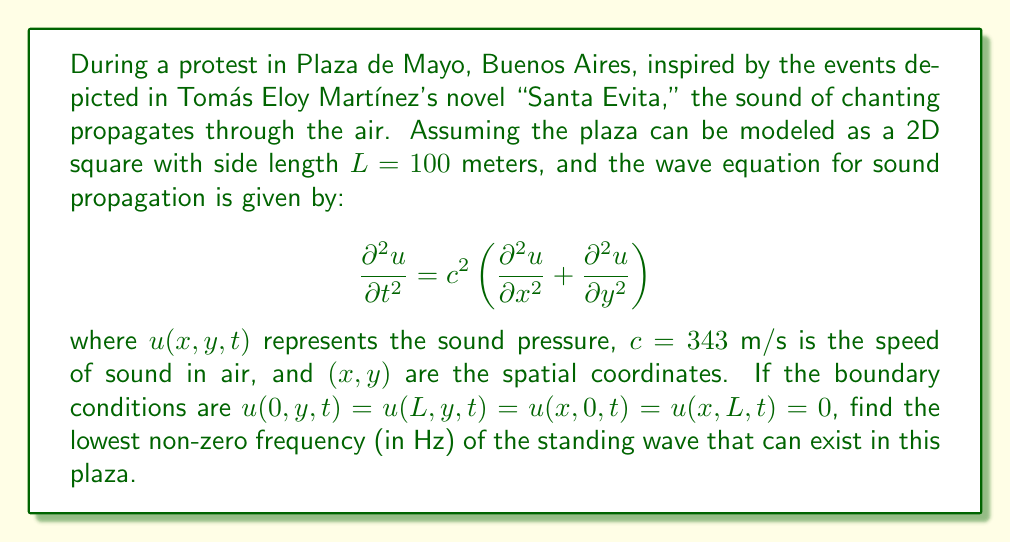What is the answer to this math problem? To solve this problem, we need to follow these steps:

1) The general solution for the wave equation in 2D with the given boundary conditions is:

   $$u(x,y,t) = \sum_{m,n=1}^{\infty} A_{mn} \sin\left(\frac{m\pi x}{L}\right) \sin\left(\frac{n\pi y}{L}\right) \cos(\omega_{mn}t + \phi_{mn})$$

   where $A_{mn}$ and $\phi_{mn}$ are determined by initial conditions, and $\omega_{mn}$ is the angular frequency.

2) Substituting this solution into the wave equation, we get:

   $$-\omega_{mn}^2 = c^2\left[-\left(\frac{m\pi}{L}\right)^2 - \left(\frac{n\pi}{L}\right)^2\right]$$

3) Solving for $\omega_{mn}$:

   $$\omega_{mn} = c\pi\sqrt{\frac{m^2+n^2}{L^2}}$$

4) The frequency $f_{mn}$ is related to $\omega_{mn}$ by $f_{mn} = \frac{\omega_{mn}}{2\pi}$:

   $$f_{mn} = \frac{c}{2L}\sqrt{m^2+n^2}$$

5) The lowest non-zero frequency occurs when $m=1$ and $n=1$:

   $$f_{11} = \frac{c}{2L}\sqrt{1^2+1^2} = \frac{c}{2L}\sqrt{2}$$

6) Substituting the given values:

   $$f_{11} = \frac{343}{2(100)}\sqrt{2} \approx 2.424 \text{ Hz}$$

This frequency represents the fundamental mode of vibration in the plaza, which could be related to the rhythmic chanting of protesters in Martínez's fictional account of political unrest.
Answer: The lowest non-zero frequency of the standing wave that can exist in the plaza is approximately 2.424 Hz. 